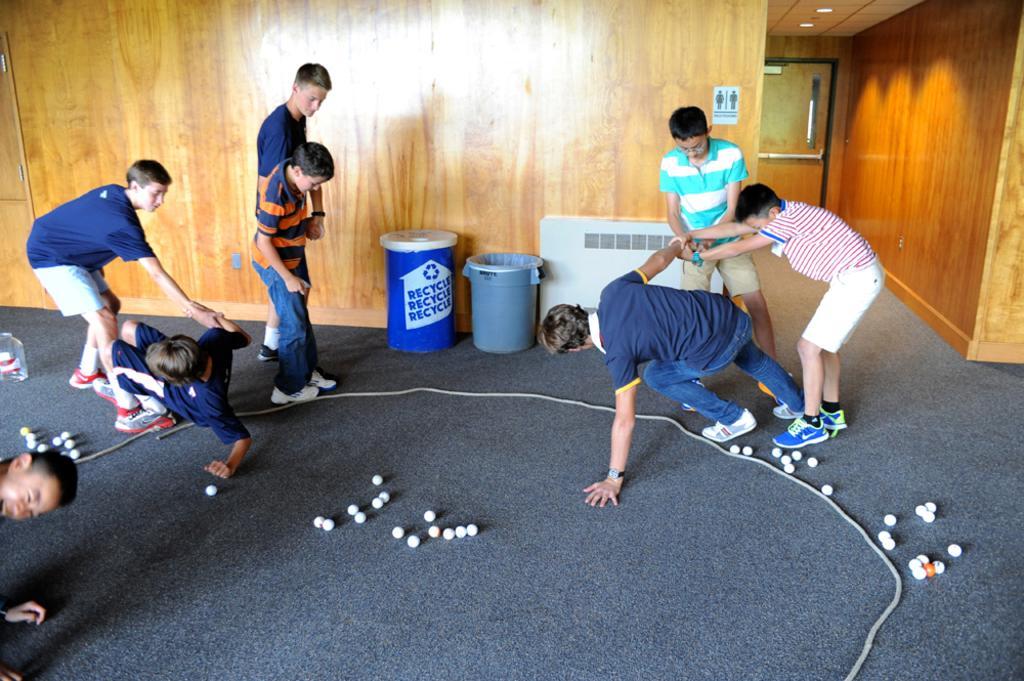Describe this image in one or two sentences. In this image there are few boys standing on the floor and holding the hand of the other persons. There are few dustbins, ropes and few balls are on the floor. Behind dustbins there is wooden wall. There is a door to the wall. There is a poster attached to the wall. Few lights are attached to the roof. 